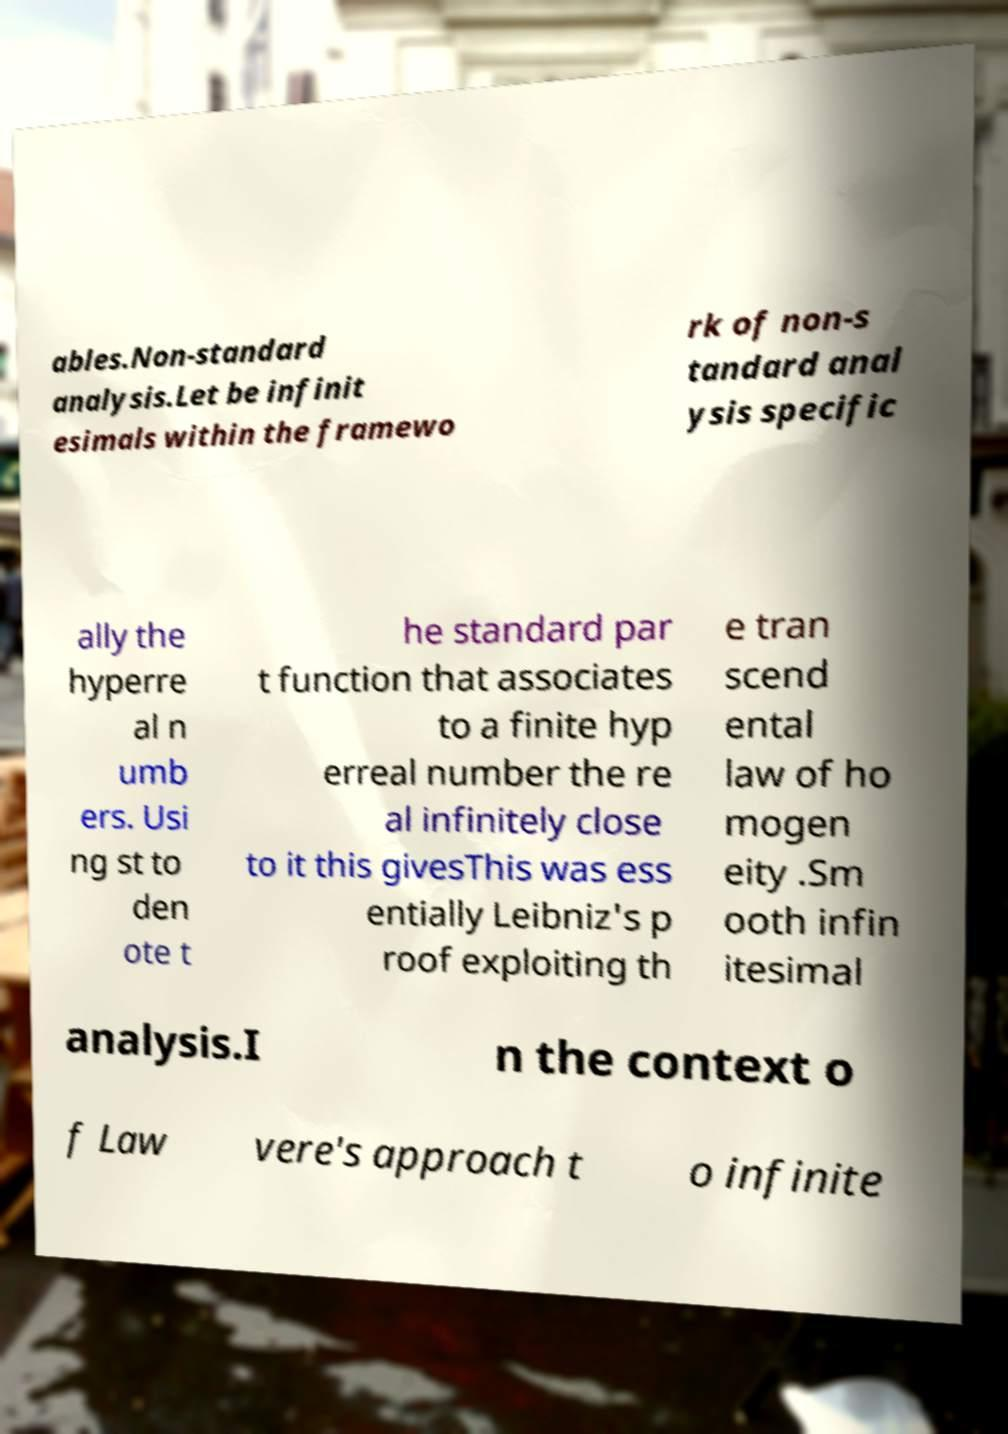There's text embedded in this image that I need extracted. Can you transcribe it verbatim? ables.Non-standard analysis.Let be infinit esimals within the framewo rk of non-s tandard anal ysis specific ally the hyperre al n umb ers. Usi ng st to den ote t he standard par t function that associates to a finite hyp erreal number the re al infinitely close to it this givesThis was ess entially Leibniz's p roof exploiting th e tran scend ental law of ho mogen eity .Sm ooth infin itesimal analysis.I n the context o f Law vere's approach t o infinite 